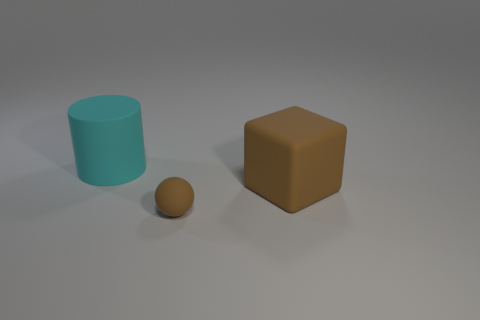What size is the cube?
Offer a very short reply. Large. Do the matte cylinder and the brown rubber sphere have the same size?
Make the answer very short. No. What material is the object to the left of the tiny rubber thing?
Make the answer very short. Rubber. There is a large object that is in front of the cyan rubber cylinder; are there any brown things that are behind it?
Ensure brevity in your answer.  No. Do the cyan thing and the small brown rubber thing have the same shape?
Your answer should be compact. No. What is the shape of the big brown object that is the same material as the cyan thing?
Keep it short and to the point. Cube. Do the rubber cube that is on the right side of the brown ball and the matte thing that is left of the brown matte ball have the same size?
Make the answer very short. Yes. Is the number of cyan rubber cylinders to the right of the large cyan cylinder greater than the number of large brown things that are to the left of the rubber sphere?
Ensure brevity in your answer.  No. How many other objects are the same color as the matte sphere?
Provide a succinct answer. 1. There is a rubber sphere; does it have the same color as the large thing to the left of the big brown block?
Ensure brevity in your answer.  No. 